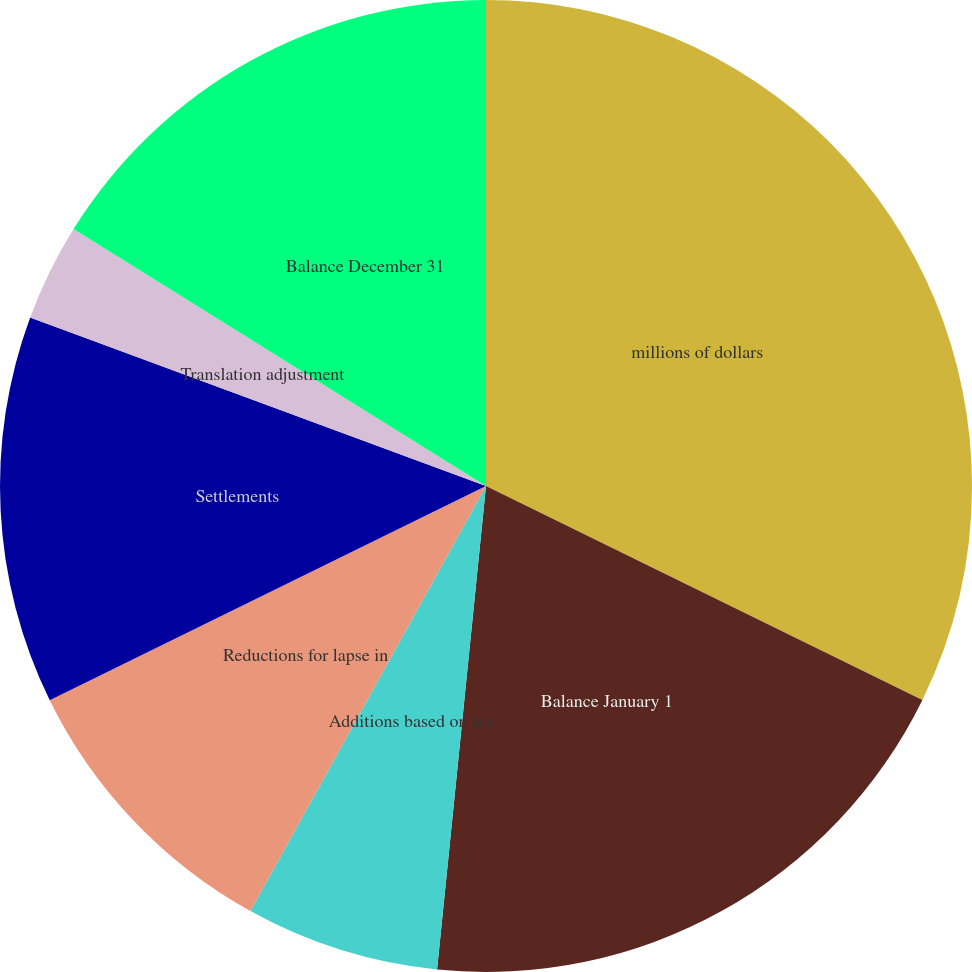Convert chart to OTSL. <chart><loc_0><loc_0><loc_500><loc_500><pie_chart><fcel>millions of dollars<fcel>Balance January 1<fcel>Additions based on tax<fcel>Additions (Reductions) for tax<fcel>Reductions for lapse in<fcel>Settlements<fcel>Translation adjustment<fcel>Balance December 31<nl><fcel>32.25%<fcel>19.35%<fcel>6.45%<fcel>0.0%<fcel>9.68%<fcel>12.9%<fcel>3.23%<fcel>16.13%<nl></chart> 